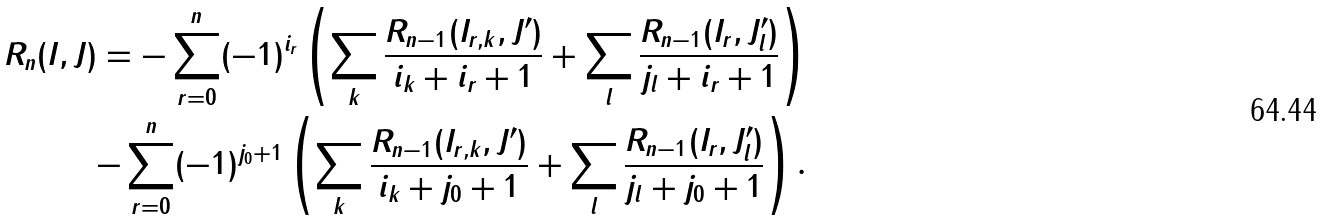Convert formula to latex. <formula><loc_0><loc_0><loc_500><loc_500>R _ { n } ( I , J ) = - \sum _ { r = 0 } ^ { n } ( - 1 ) ^ { i _ { r } } \left ( \sum _ { k } \frac { R _ { n - 1 } ( I _ { r , k } , J ^ { \prime } ) } { i _ { k } + i _ { r } + 1 } + \sum _ { l } \frac { R _ { n - 1 } ( I _ { r } , J ^ { \prime } _ { l } ) } { j _ { l } + i _ { r } + 1 } \right ) \\ - \sum _ { r = 0 } ^ { n } ( - 1 ) ^ { j _ { 0 } + 1 } \left ( \sum _ { k } \frac { R _ { n - 1 } ( I _ { r , k } , J ^ { \prime } ) } { i _ { k } + j _ { 0 } + 1 } + \sum _ { l } \frac { R _ { n - 1 } ( I _ { r } , J ^ { \prime } _ { l } ) } { j _ { l } + j _ { 0 } + 1 } \right ) .</formula> 